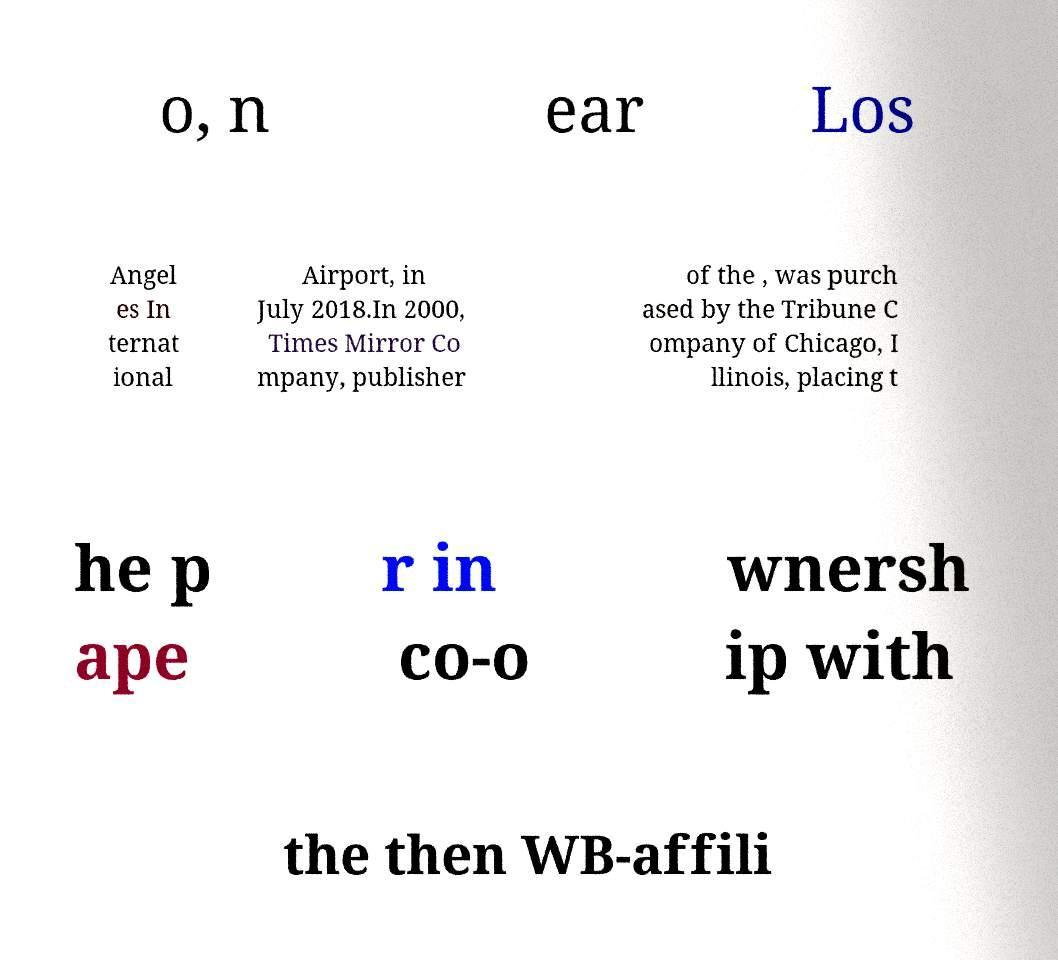What messages or text are displayed in this image? I need them in a readable, typed format. o, n ear Los Angel es In ternat ional Airport, in July 2018.In 2000, Times Mirror Co mpany, publisher of the , was purch ased by the Tribune C ompany of Chicago, I llinois, placing t he p ape r in co-o wnersh ip with the then WB-affili 